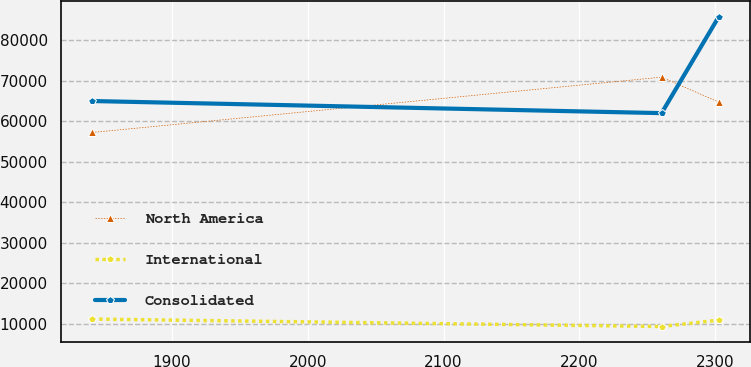<chart> <loc_0><loc_0><loc_500><loc_500><line_chart><ecel><fcel>North America<fcel>International<fcel>Consolidated<nl><fcel>1841.48<fcel>57259.9<fcel>11167.9<fcel>65024.1<nl><fcel>2260.49<fcel>70922<fcel>9329.82<fcel>62040<nl><fcel>2302.67<fcel>64754.2<fcel>10910.3<fcel>85902.8<nl></chart> 